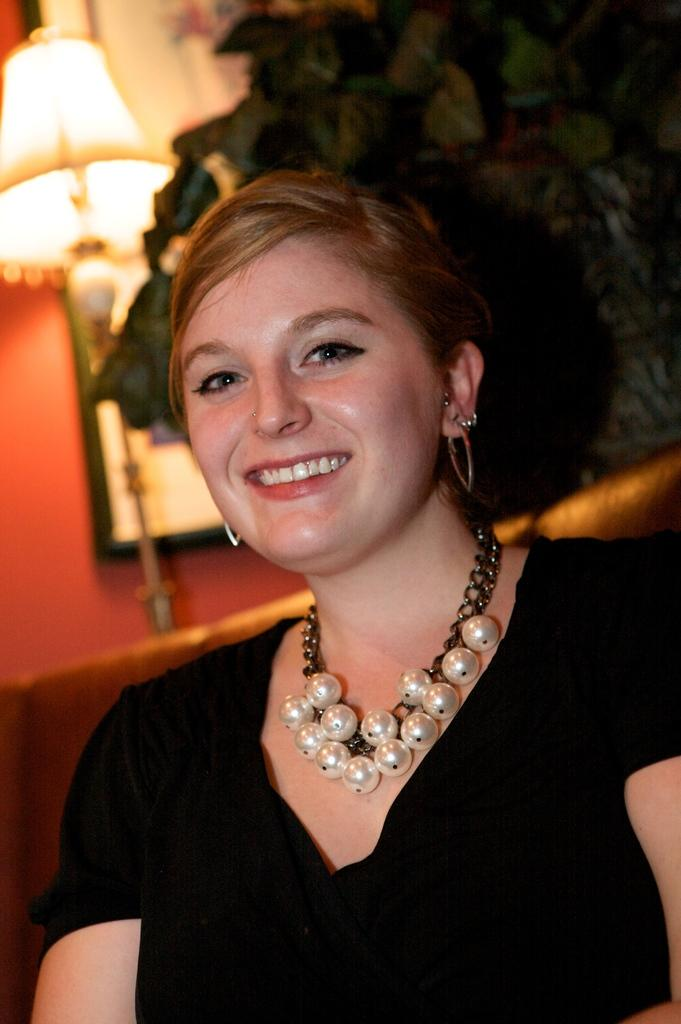What is the lady in the image doing? The lady is sitting on the couch in the image. What type of plant can be seen in the image? There is a house plant in the image. What is another object visible in the room? There is a lamp in the image. What is hanging on the wall in the image? There is a photo frame on the wall. What type of jewel is the lady wearing in the image? There is no mention of a jewel in the image, so we cannot determine if the lady is wearing one. 